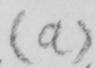Please transcribe the handwritten text in this image. (a) 